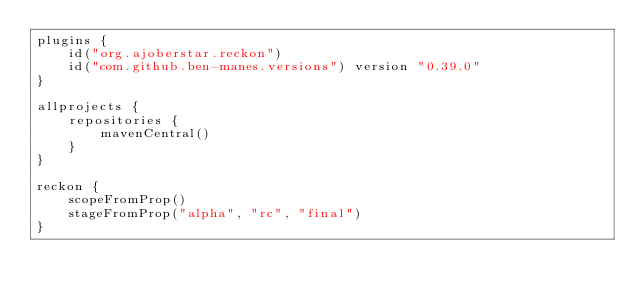Convert code to text. <code><loc_0><loc_0><loc_500><loc_500><_Kotlin_>plugins {
    id("org.ajoberstar.reckon")
    id("com.github.ben-manes.versions") version "0.39.0"
}

allprojects {
    repositories {
        mavenCentral()
    }
}

reckon {
    scopeFromProp()
    stageFromProp("alpha", "rc", "final")
}
</code> 